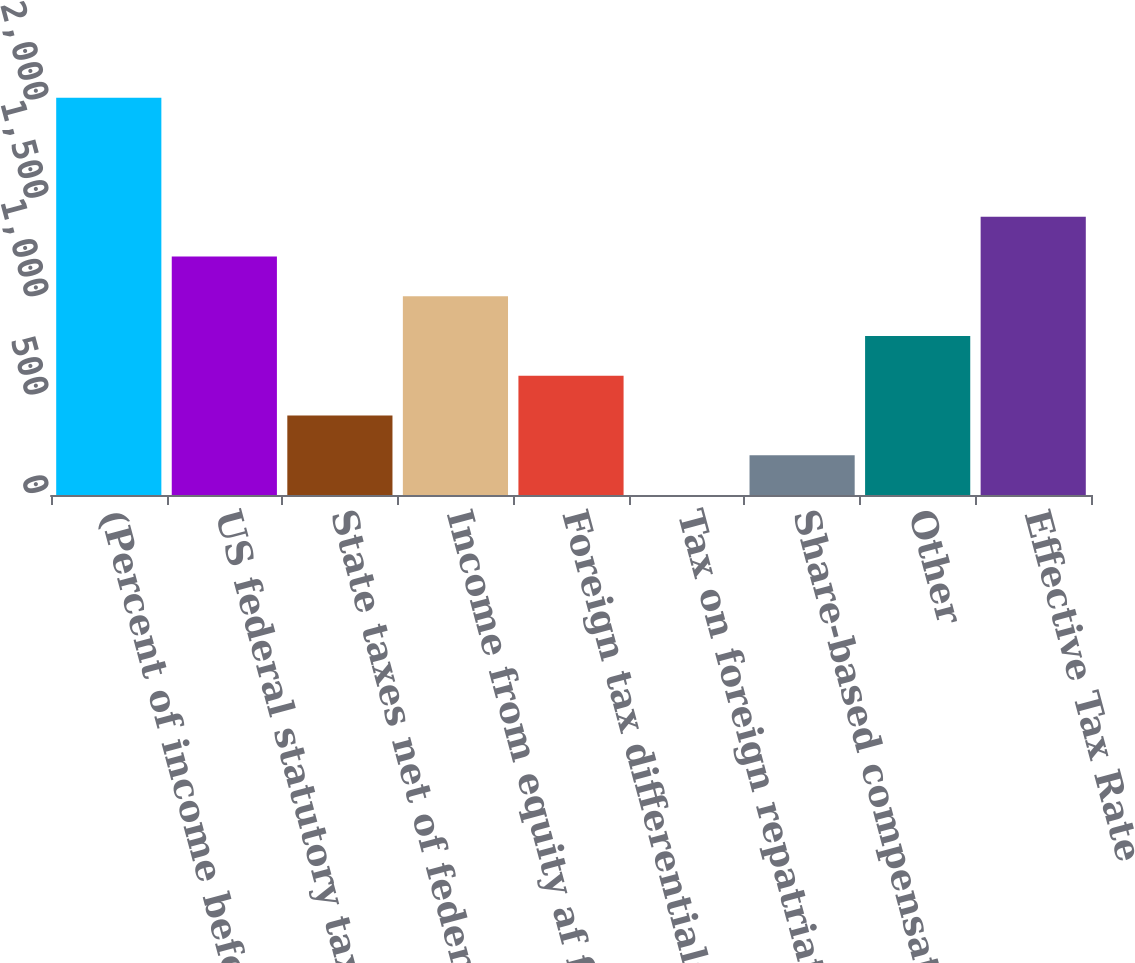Convert chart. <chart><loc_0><loc_0><loc_500><loc_500><bar_chart><fcel>(Percent of income before<fcel>US federal statutory tax rate<fcel>State taxes net of federal<fcel>Income from equity af filiates<fcel>Foreign tax differentials<fcel>Tax on foreign repatriated<fcel>Share-based compensation<fcel>Other<fcel>Effective Tax Rate<nl><fcel>2019<fcel>1211.44<fcel>403.88<fcel>1009.55<fcel>605.77<fcel>0.1<fcel>201.99<fcel>807.66<fcel>1413.33<nl></chart> 